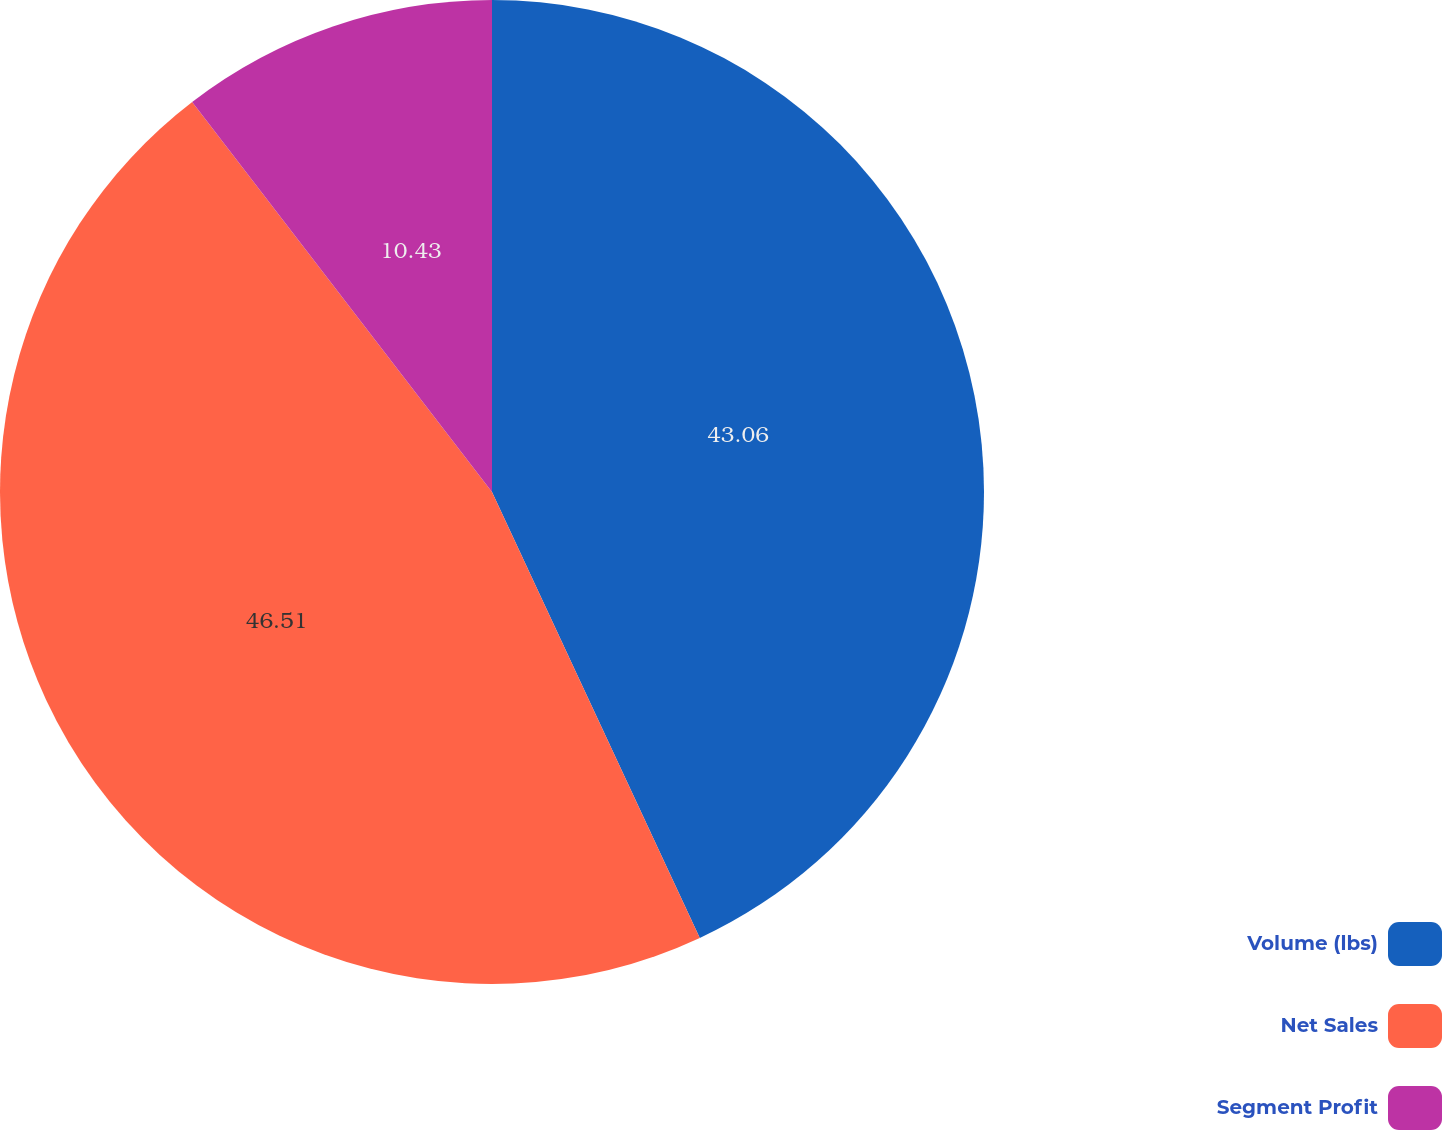Convert chart. <chart><loc_0><loc_0><loc_500><loc_500><pie_chart><fcel>Volume (lbs)<fcel>Net Sales<fcel>Segment Profit<nl><fcel>43.06%<fcel>46.51%<fcel>10.43%<nl></chart> 